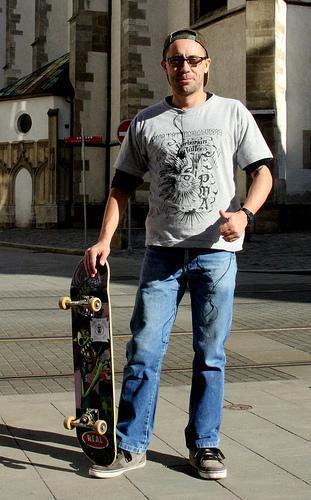How many people are visible?
Give a very brief answer. 1. How many skateboard wheels are visible?
Give a very brief answer. 4. 